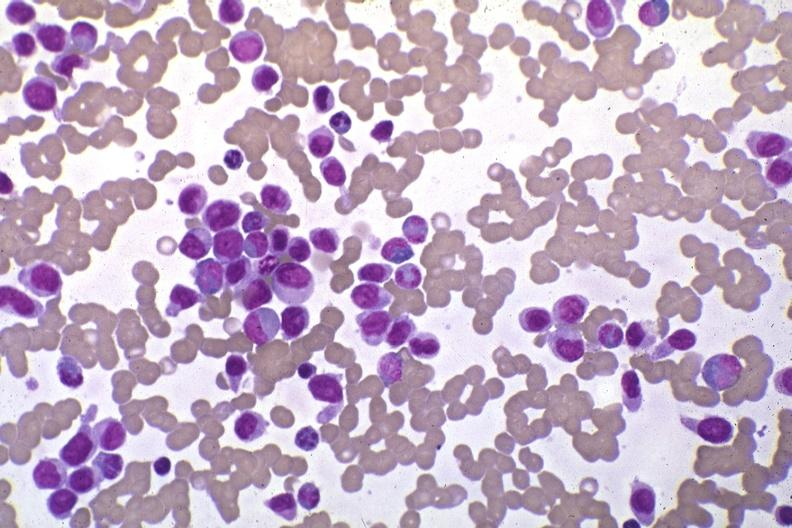s hematologic present?
Answer the question using a single word or phrase. Yes 